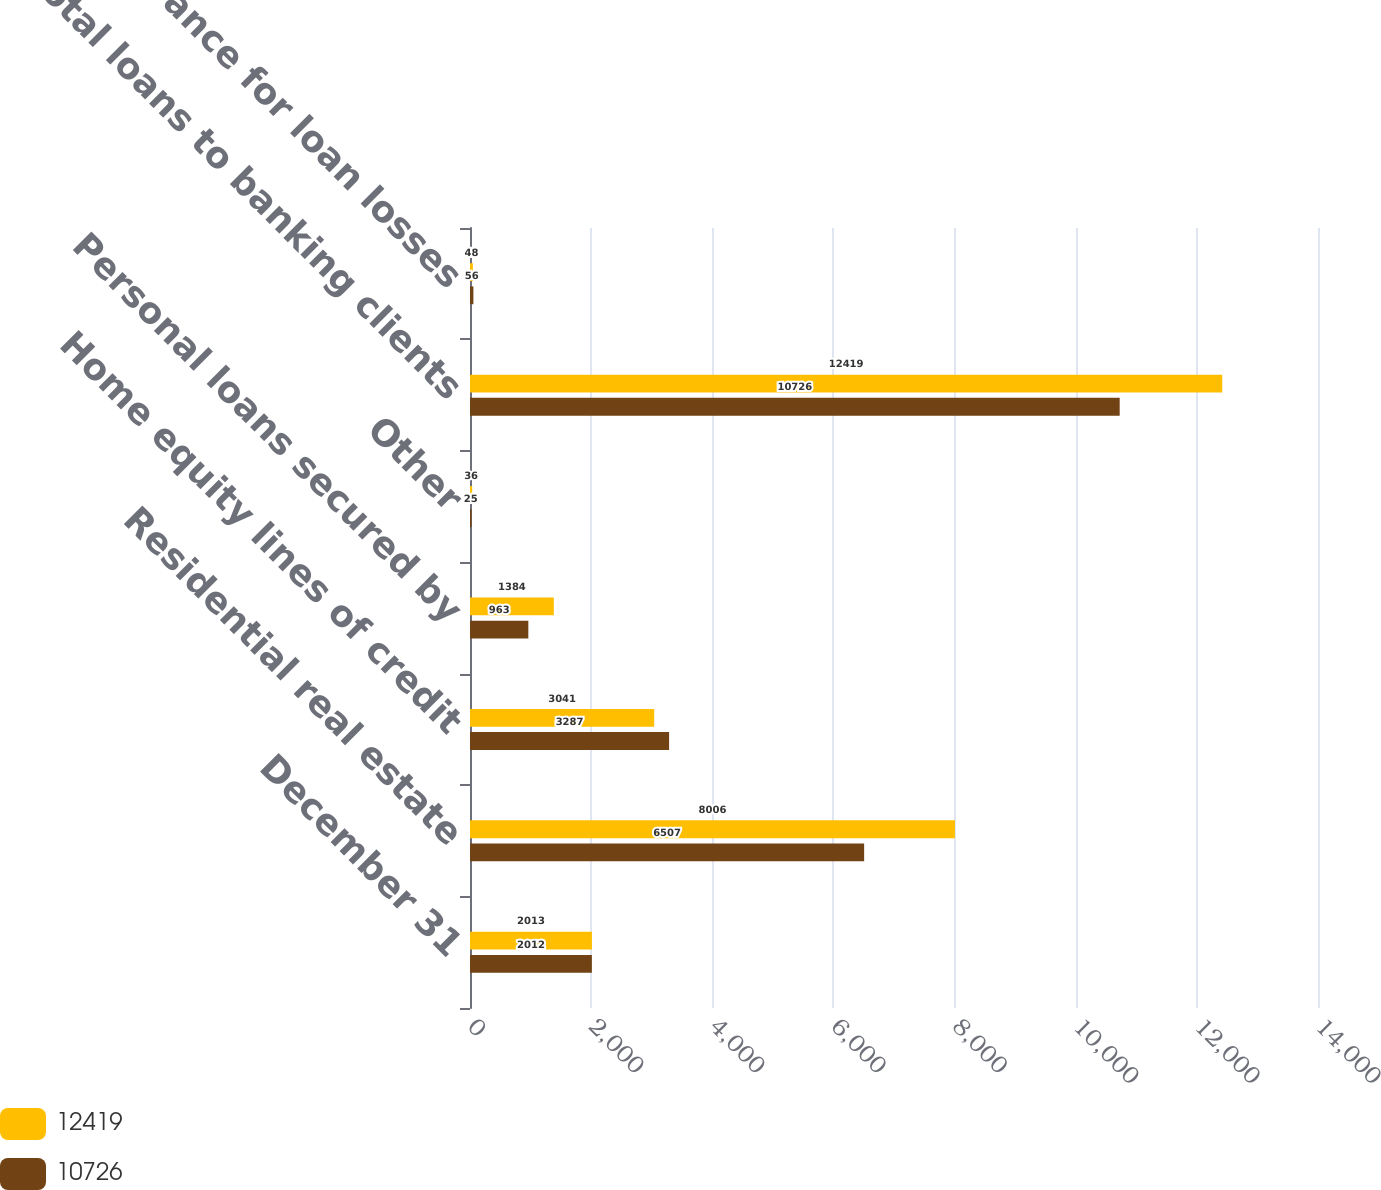<chart> <loc_0><loc_0><loc_500><loc_500><stacked_bar_chart><ecel><fcel>December 31<fcel>Residential real estate<fcel>Home equity lines of credit<fcel>Personal loans secured by<fcel>Other<fcel>Total loans to banking clients<fcel>Allowance for loan losses<nl><fcel>12419<fcel>2013<fcel>8006<fcel>3041<fcel>1384<fcel>36<fcel>12419<fcel>48<nl><fcel>10726<fcel>2012<fcel>6507<fcel>3287<fcel>963<fcel>25<fcel>10726<fcel>56<nl></chart> 